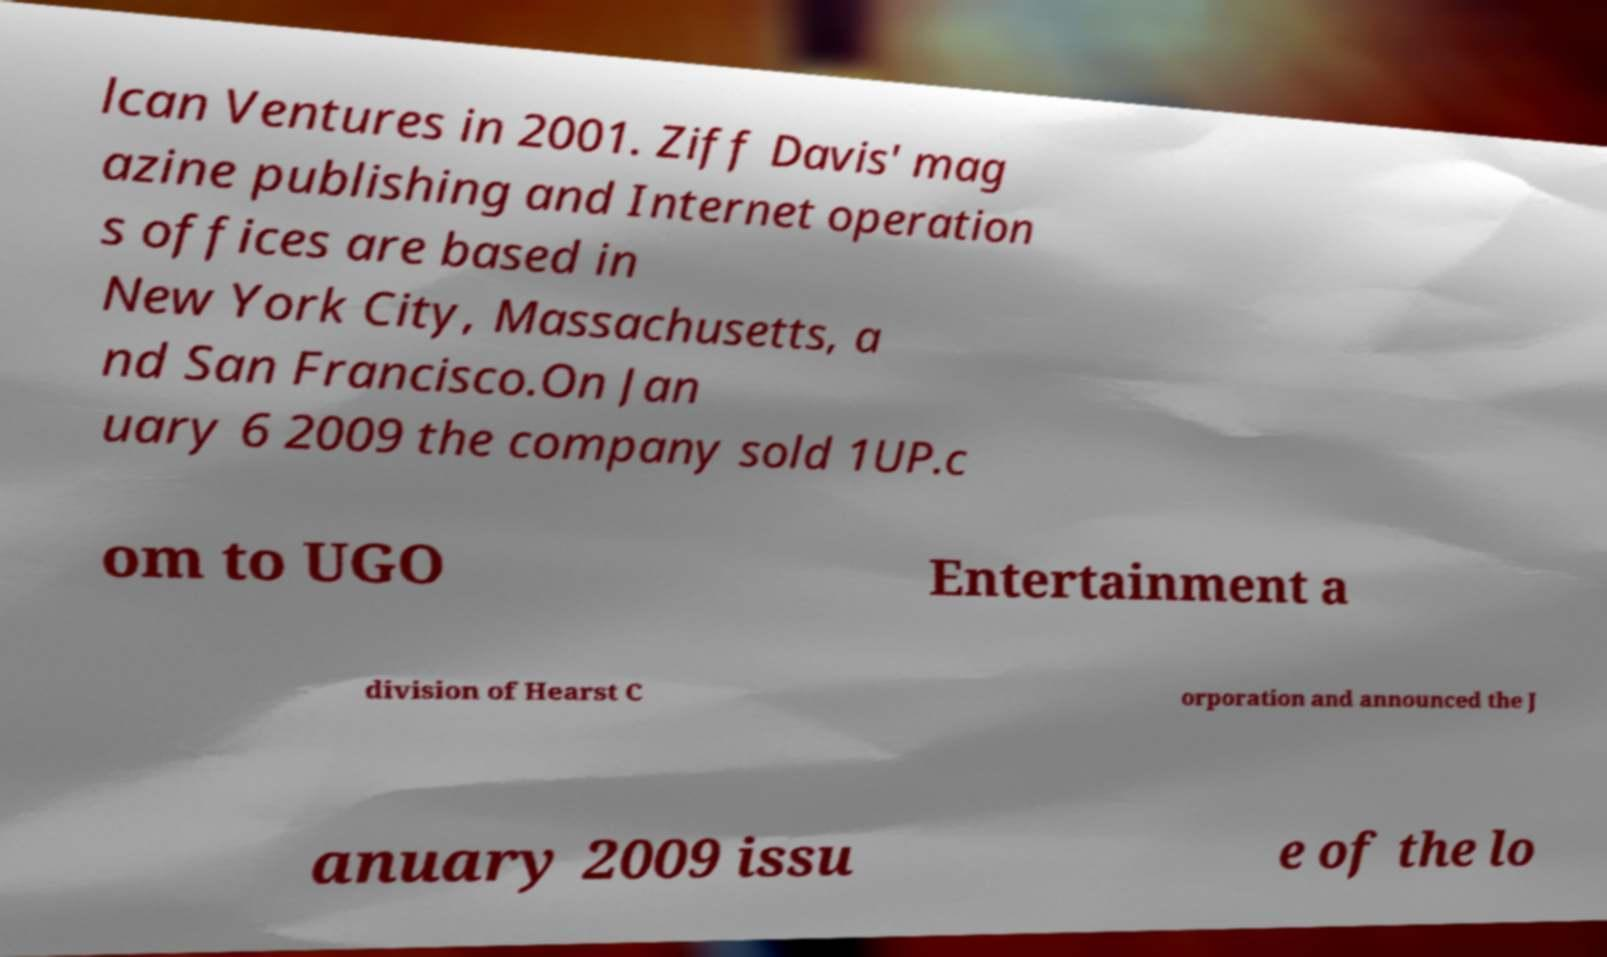Please read and relay the text visible in this image. What does it say? lcan Ventures in 2001. Ziff Davis' mag azine publishing and Internet operation s offices are based in New York City, Massachusetts, a nd San Francisco.On Jan uary 6 2009 the company sold 1UP.c om to UGO Entertainment a division of Hearst C orporation and announced the J anuary 2009 issu e of the lo 